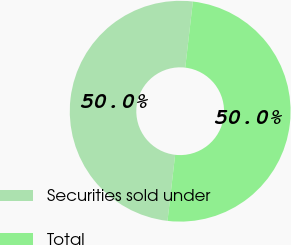Convert chart. <chart><loc_0><loc_0><loc_500><loc_500><pie_chart><fcel>Securities sold under<fcel>Total<nl><fcel>50.0%<fcel>50.0%<nl></chart> 